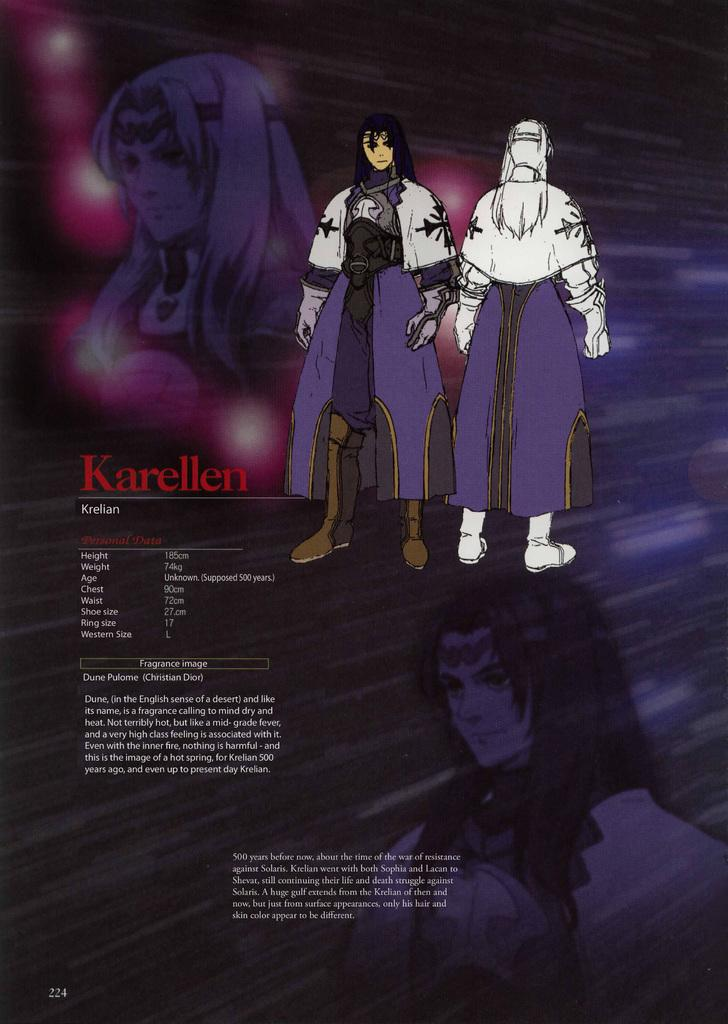What type of magazine is shown in the image? There is a purple color cartoon magazine in the image. Can you describe the characters in the image? There are two cartoon men in the image. What additional information is provided alongside the magazine? There is some information beside the cartoon magazine. What type of silk material is used to create the cobweb in the image? There is no silk material or cobweb present in the image. 